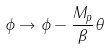Convert formula to latex. <formula><loc_0><loc_0><loc_500><loc_500>\phi \rightarrow \phi - \frac { M _ { p } } { \beta } \theta</formula> 